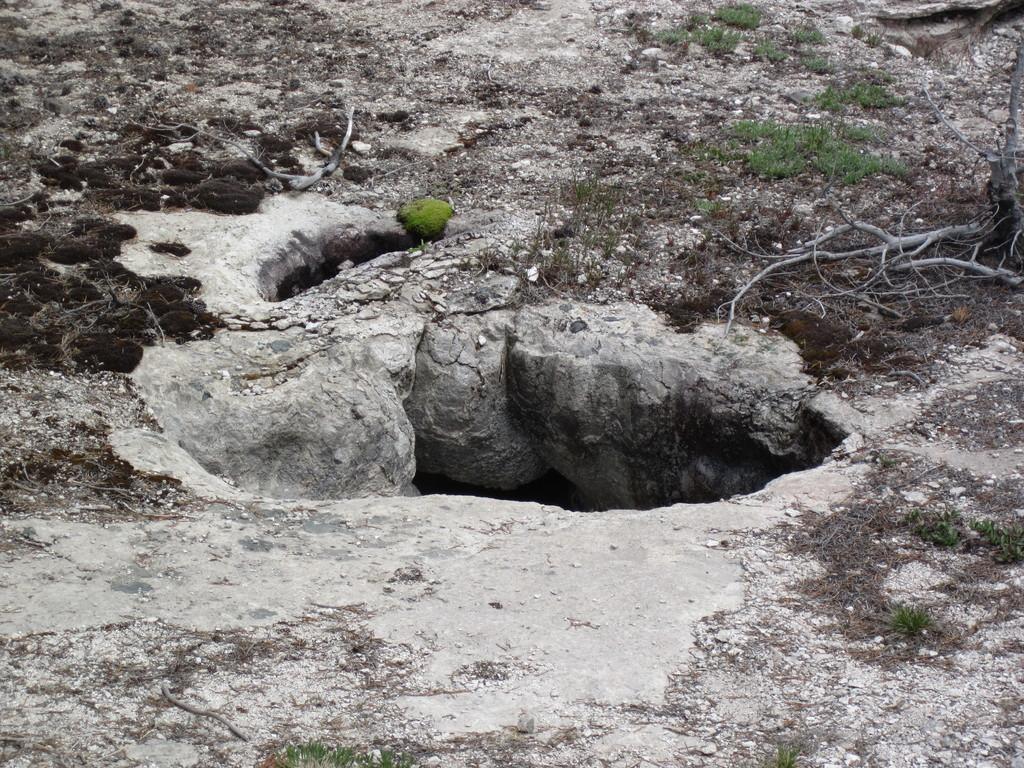In one or two sentences, can you explain what this image depicts? In this image we can see the pit. We can also see the grass and also the stems. 